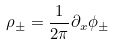Convert formula to latex. <formula><loc_0><loc_0><loc_500><loc_500>\rho _ { \pm } = \frac { 1 } { 2 \pi } \partial _ { x } \phi _ { \pm }</formula> 